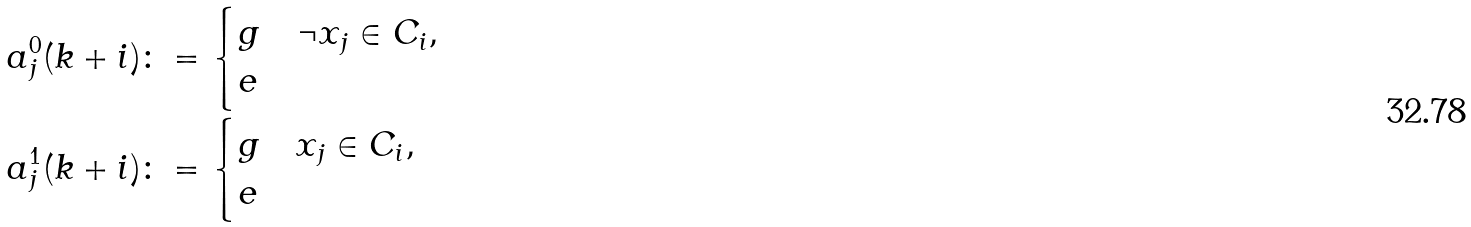<formula> <loc_0><loc_0><loc_500><loc_500>a _ { j } ^ { 0 } ( k + i ) & \colon = \begin{cases} g & \neg x _ { j } \in C _ { i } , \\ e & \end{cases} \\ a _ { j } ^ { 1 } ( k + i ) & \colon = \begin{cases} g & x _ { j } \in C _ { i } , \\ e & \end{cases}</formula> 